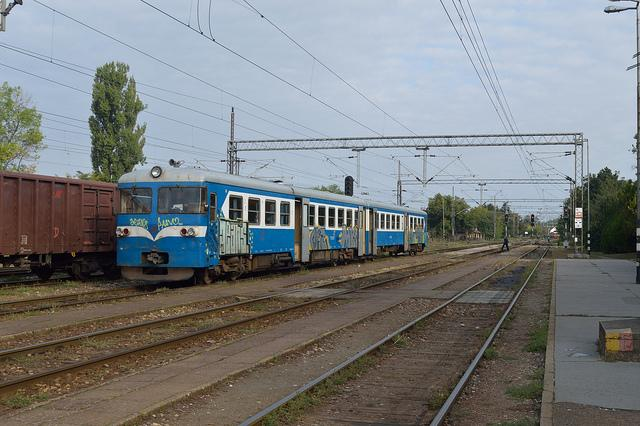What is the name of the painting on the outside of the blue train? graffiti 